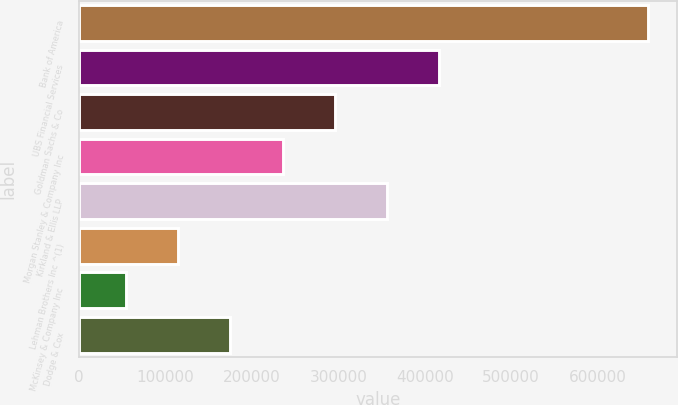Convert chart to OTSL. <chart><loc_0><loc_0><loc_500><loc_500><bar_chart><fcel>Bank of America<fcel>UBS Financial Services<fcel>Goldman Sachs & Co<fcel>Morgan Stanley & Company Inc<fcel>Kirkland & Ellis LLP<fcel>Lehman Brothers Inc ^(1)<fcel>McKinsey & Company Inc<fcel>Dodge & Cox<nl><fcel>659000<fcel>417000<fcel>296000<fcel>235500<fcel>356500<fcel>114500<fcel>54000<fcel>175000<nl></chart> 